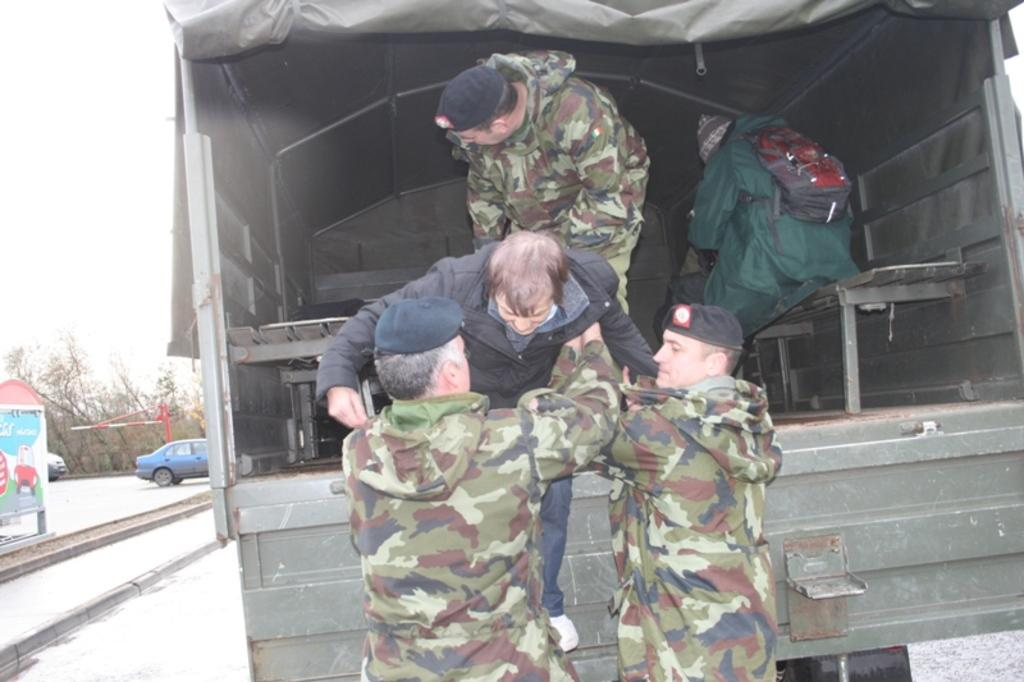How many people are in the image? There is a group of people in the image, but the exact number is not specified. What else can be seen on the road in the image? There are vehicles on the road in the image. What is the tall, vertical object in the image? There appears to be a pole in the image. What type of vegetation is present in the image? There are trees in the image. What is visible in the background of the image? The sky is visible in the background of the image. How many bikes are being ridden by the visitors in the image? There is no mention of bikes or visitors in the image. What verse is being recited by the trees in the image? Trees do not recite verses, and there is no indication of any recitation in the image. 